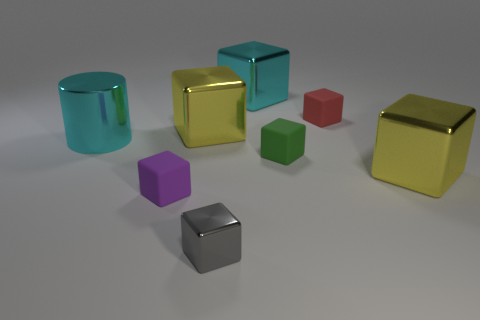What number of cylinders are either cyan metallic objects or green things?
Your response must be concise. 1. Are there any tiny purple blocks that are on the right side of the matte object in front of the yellow metallic block to the right of the tiny red cube?
Your answer should be compact. No. What is the color of the tiny metal object that is the same shape as the green matte thing?
Provide a short and direct response. Gray. How many green things are either small cubes or cubes?
Give a very brief answer. 1. What is the yellow thing behind the cyan metallic object left of the purple matte cube made of?
Give a very brief answer. Metal. Does the small red rubber object have the same shape as the small gray thing?
Make the answer very short. Yes. What is the color of the metal cube that is the same size as the purple matte thing?
Ensure brevity in your answer.  Gray. Is there a shiny thing of the same color as the small metal block?
Provide a short and direct response. No. Are any cyan metal objects visible?
Your answer should be very brief. Yes. Do the large yellow cube that is to the right of the gray thing and the small gray block have the same material?
Offer a terse response. Yes. 